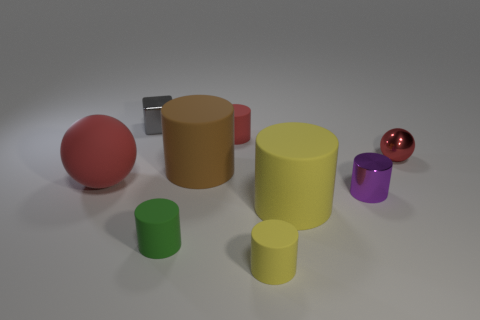Do the sphere to the left of the big yellow cylinder and the small shiny ball have the same color?
Give a very brief answer. Yes. What number of other things are the same size as the green matte thing?
Offer a terse response. 5. Is the material of the tiny purple object the same as the tiny gray thing?
Offer a terse response. Yes. The ball in front of the red sphere on the right side of the large brown matte cylinder is what color?
Ensure brevity in your answer.  Red. There is a red rubber thing that is the same shape as the green object; what size is it?
Provide a succinct answer. Small. Is the tiny ball the same color as the large rubber ball?
Make the answer very short. Yes. How many yellow rubber cylinders are on the left side of the metallic object that is to the left of the tiny red thing on the left side of the metal cylinder?
Your response must be concise. 0. Is the number of large brown rubber blocks greater than the number of green rubber cylinders?
Your answer should be compact. No. How many gray objects are there?
Give a very brief answer. 1. The object that is left of the small metal thing left of the cylinder that is in front of the small green cylinder is what shape?
Keep it short and to the point. Sphere. 